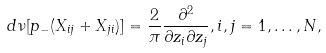<formula> <loc_0><loc_0><loc_500><loc_500>d \nu [ p _ { - } ( X _ { i j } + X _ { j i } ) ] = \frac { 2 } { \pi } \frac { \partial ^ { 2 } } { \partial z _ { i } \partial z _ { j } } , i , j = 1 , \dots , N ,</formula> 